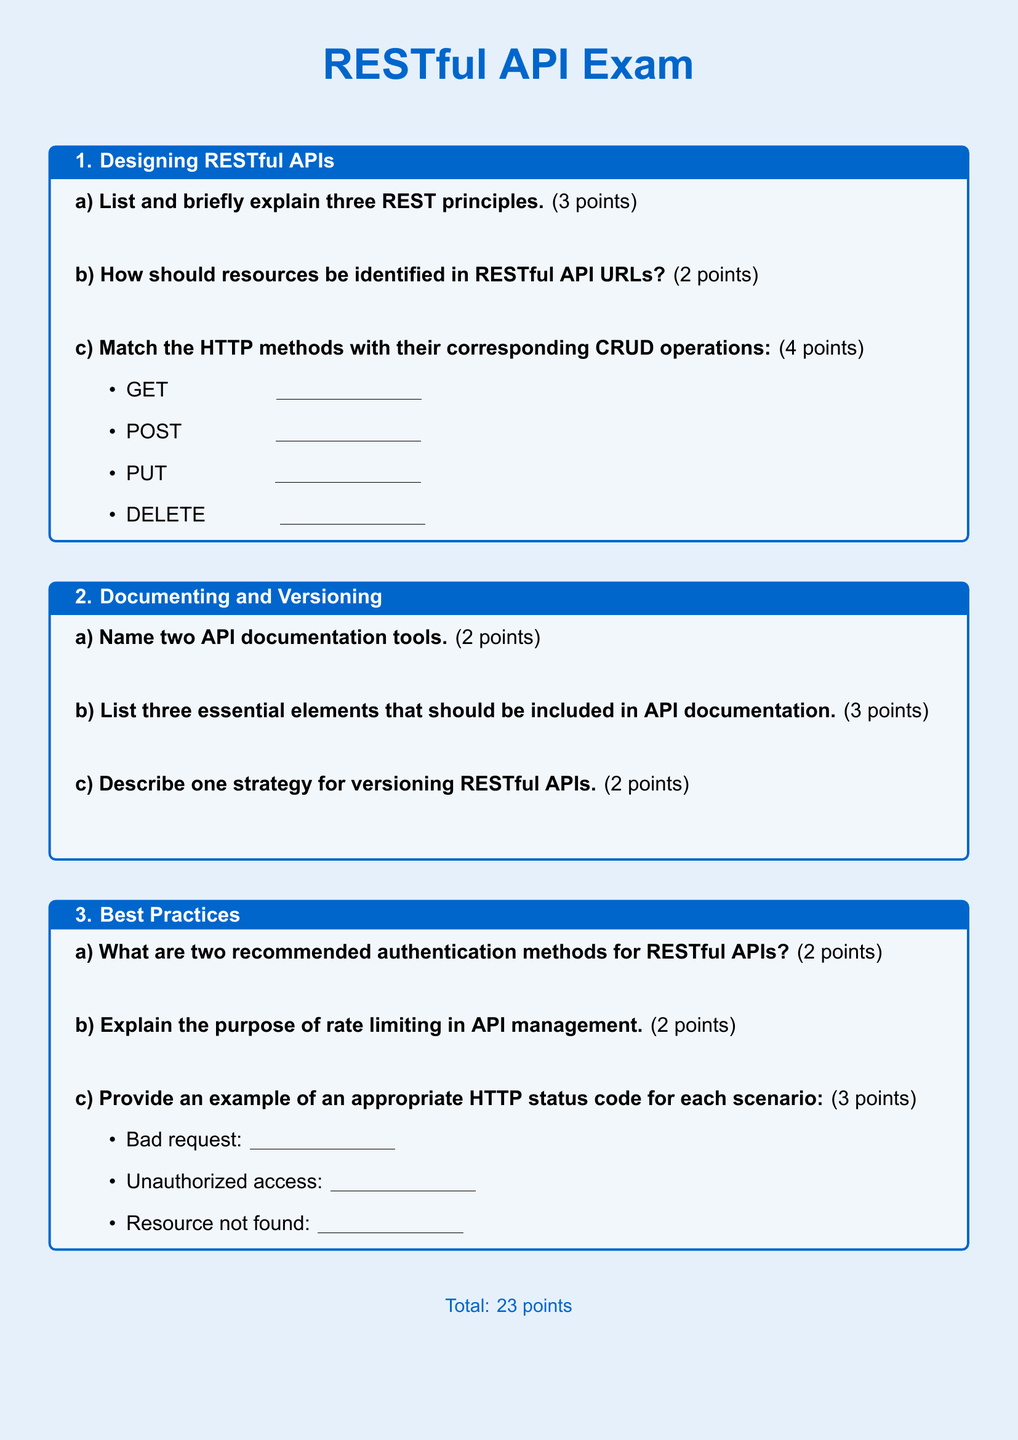What are the three REST principles? The document asks for a list and brief explanation of three REST principles, which are fundamental concepts in RESTful API design.
Answer: Three REST principles How should resources be identified in RESTful API URLs? The document specifically mentions a question regarding the identification of resources in the context of RESTful API URLs.
Answer: Unique identifiers Name two API documentation tools. This question is found in the section about documenting RESTful APIs, where it asks for tools used to document APIs.
Answer: Swagger, Postman What are two recommended authentication methods for RESTful APIs? The document lists a question that seeks to identify recommended authentication methods for securing RESTful APIs.
Answer: OAuth, JWT What is the purpose of rate limiting in API management? The document includes a question that aims to explain the significance of rate limiting as a best practice in API management.
Answer: Prevent abuse Provide an example of an appropriate HTTP status code for bad request. The document presents a question that requires an example of an HTTP status code relevant to a bad request scenario.
Answer: 400 What is the total point value of the exam? The document concludes with a section indicating the total points of the exam.
Answer: 23 points List three essential elements that should be included in API documentation. This question appears in a section that discusses the crucial components necessary for thorough API documentation.
Answer: Overview, examples, authentication Describe one strategy for versioning RESTful APIs. The document requests a description of a strategy for API versioning, which is essential for maintaining compatibility.
Answer: URI versioning 